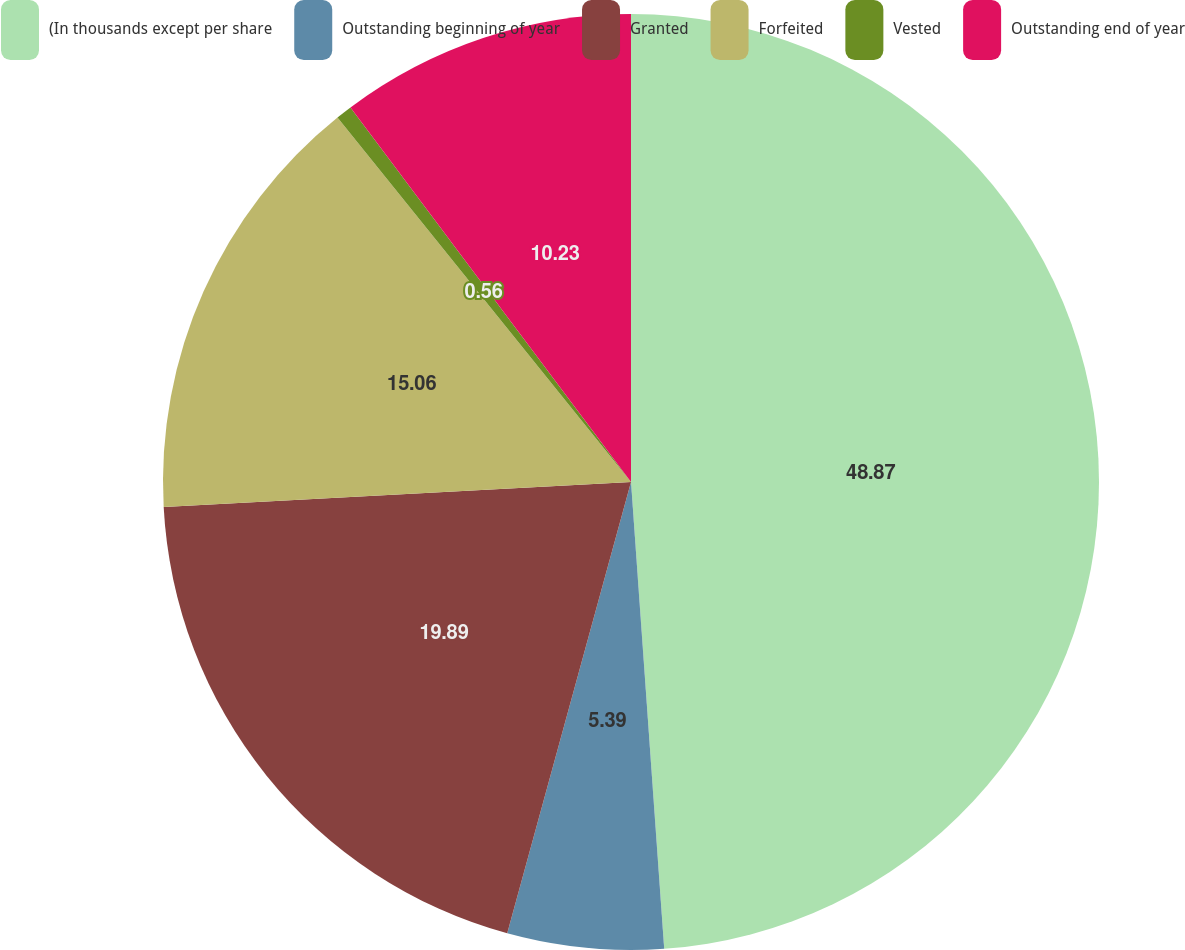<chart> <loc_0><loc_0><loc_500><loc_500><pie_chart><fcel>(In thousands except per share<fcel>Outstanding beginning of year<fcel>Granted<fcel>Forfeited<fcel>Vested<fcel>Outstanding end of year<nl><fcel>48.87%<fcel>5.39%<fcel>19.89%<fcel>15.06%<fcel>0.56%<fcel>10.23%<nl></chart> 